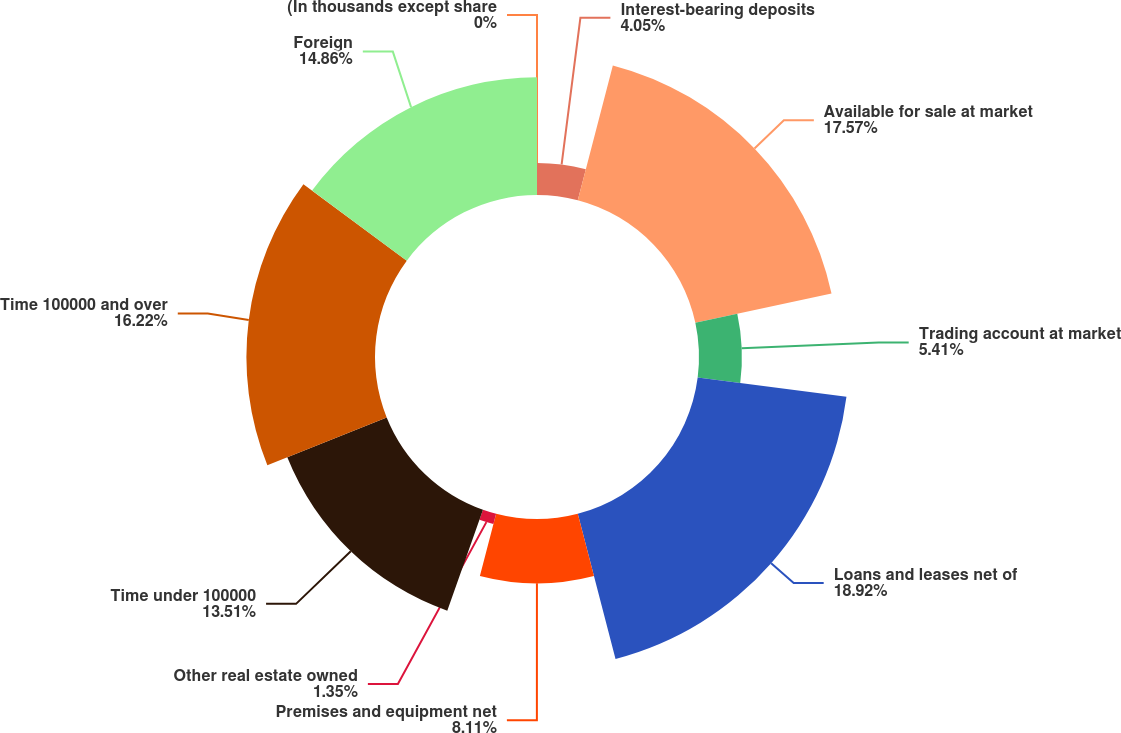Convert chart. <chart><loc_0><loc_0><loc_500><loc_500><pie_chart><fcel>(In thousands except share<fcel>Interest-bearing deposits<fcel>Available for sale at market<fcel>Trading account at market<fcel>Loans and leases net of<fcel>Premises and equipment net<fcel>Other real estate owned<fcel>Time under 100000<fcel>Time 100000 and over<fcel>Foreign<nl><fcel>0.0%<fcel>4.05%<fcel>17.57%<fcel>5.41%<fcel>18.92%<fcel>8.11%<fcel>1.35%<fcel>13.51%<fcel>16.22%<fcel>14.86%<nl></chart> 